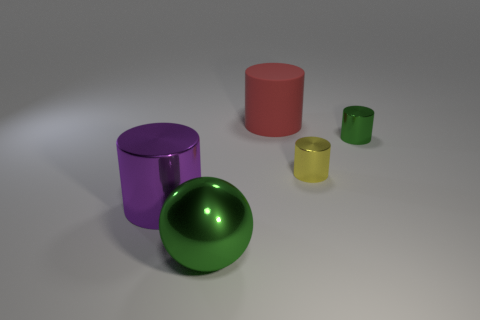What size is the cylinder that is the same color as the big sphere?
Make the answer very short. Small. There is a tiny shiny thing that is on the right side of the yellow object; is it the same shape as the big metal object that is on the left side of the shiny sphere?
Provide a short and direct response. Yes. Is there a tiny yellow cylinder made of the same material as the red cylinder?
Provide a succinct answer. No. How many gray things are metal spheres or big things?
Provide a short and direct response. 0. What is the size of the shiny thing that is both behind the ball and on the left side of the large matte object?
Offer a terse response. Large. Is the number of cylinders that are on the right side of the large purple shiny thing greater than the number of large red things?
Offer a very short reply. Yes. How many cylinders are either tiny green objects or red things?
Your response must be concise. 2. What shape is the large thing that is to the right of the large purple thing and left of the matte cylinder?
Make the answer very short. Sphere. Are there an equal number of large green metal objects that are on the left side of the purple metal object and green metallic spheres that are in front of the yellow shiny cylinder?
Keep it short and to the point. No. How many things are either small blue metallic blocks or small yellow metallic objects?
Give a very brief answer. 1. 